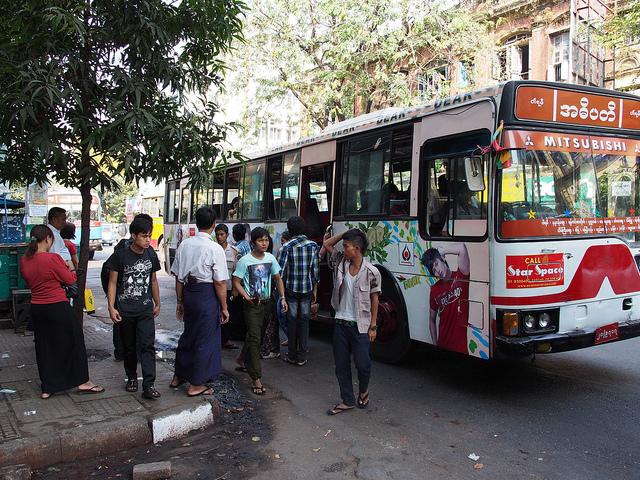What language is that on the bus?
Write a very short answer. Chinese. What are they getting on?
Answer briefly. Bus. How many people are outside the bus?
Concise answer only. 10. What are they holding?
Give a very brief answer. Nothing. What colors is the bus?
Keep it brief. White and red. How many people are in the picture?
Keep it brief. 11. 